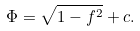Convert formula to latex. <formula><loc_0><loc_0><loc_500><loc_500>\Phi = \sqrt { 1 - f ^ { 2 } } + c .</formula> 